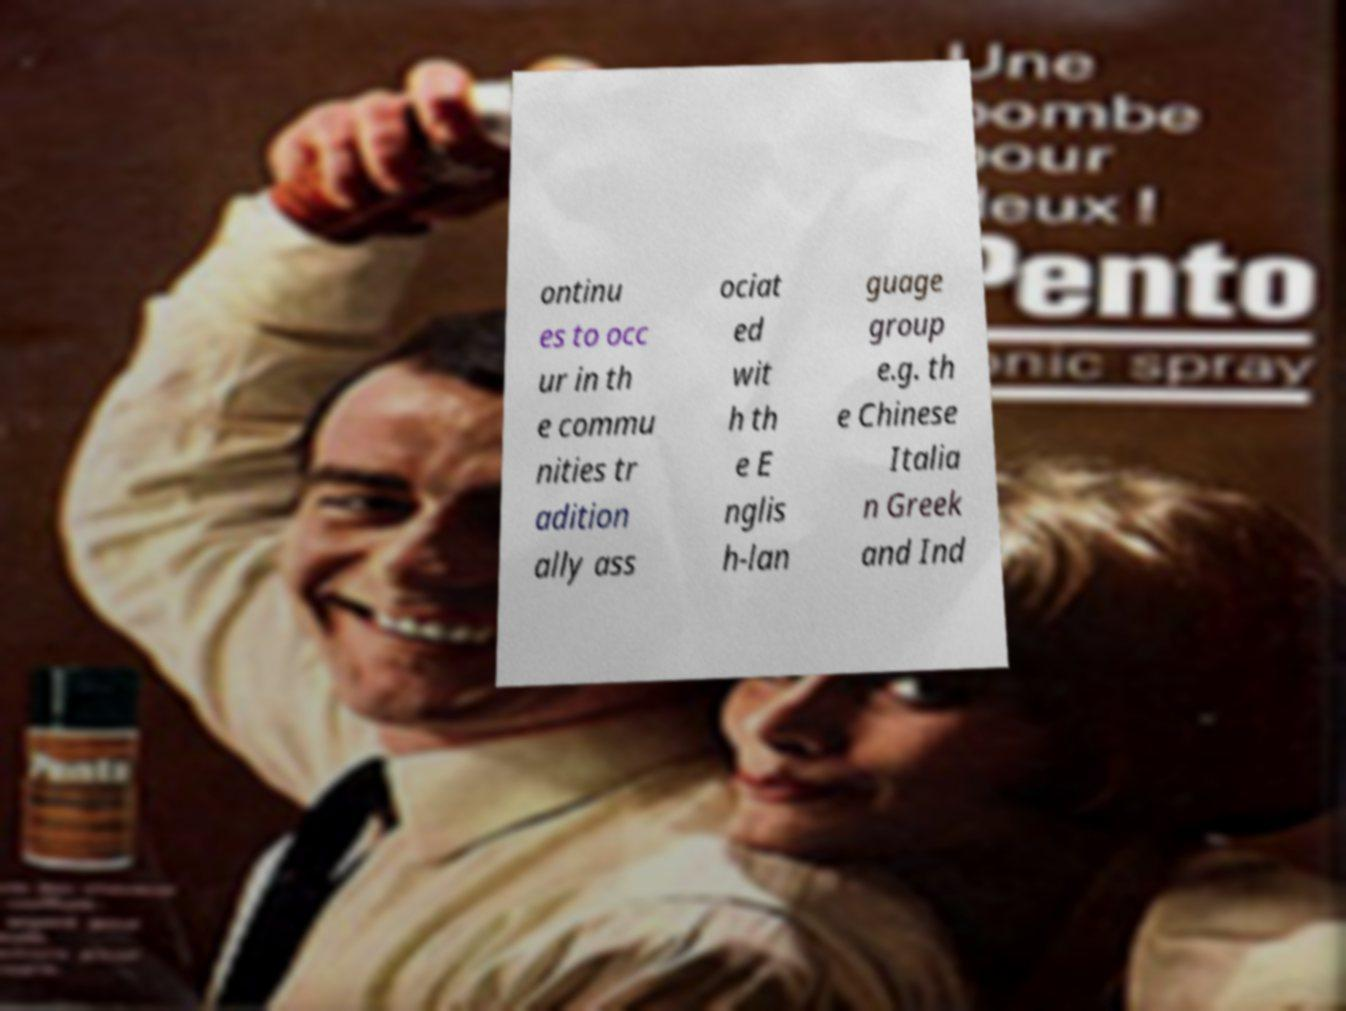Please read and relay the text visible in this image. What does it say? ontinu es to occ ur in th e commu nities tr adition ally ass ociat ed wit h th e E nglis h-lan guage group e.g. th e Chinese Italia n Greek and Ind 